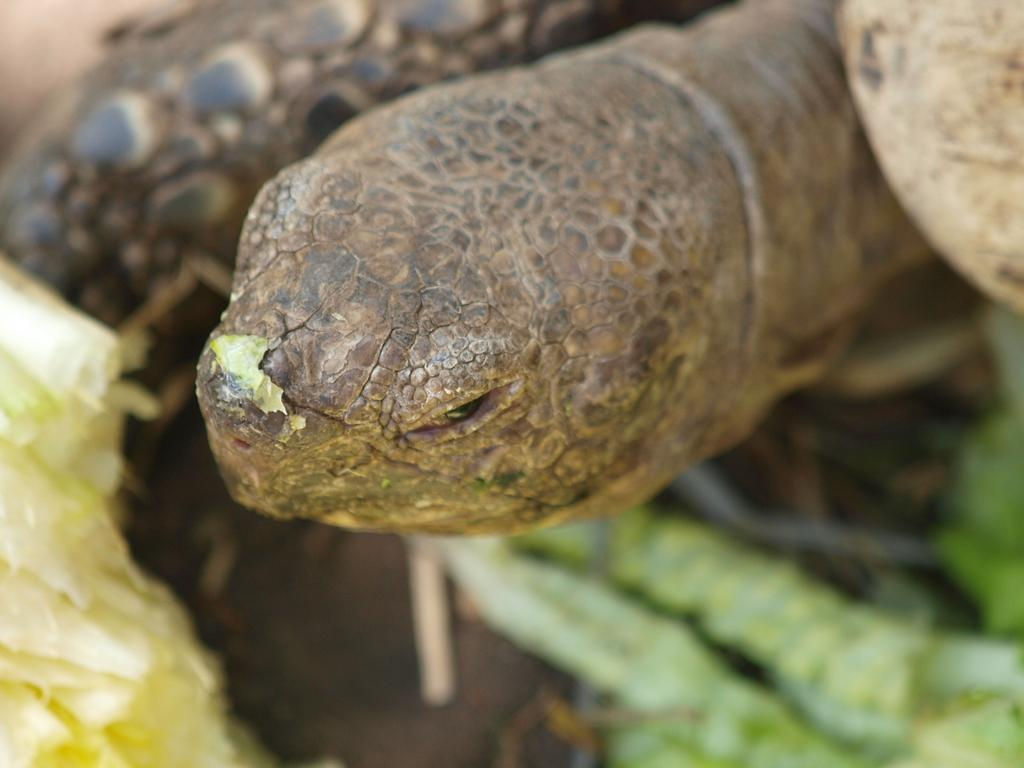What animal is present in the image? There is a tortoise in the image. What color can be observed among the objects in the image? There are green color things in the image. How would you describe the background of the image? The background of the image is slightly blurred. How does the tortoise use friction to move around in the image? The tortoise does not move around in the image, so it is not possible to determine how it would use friction. 